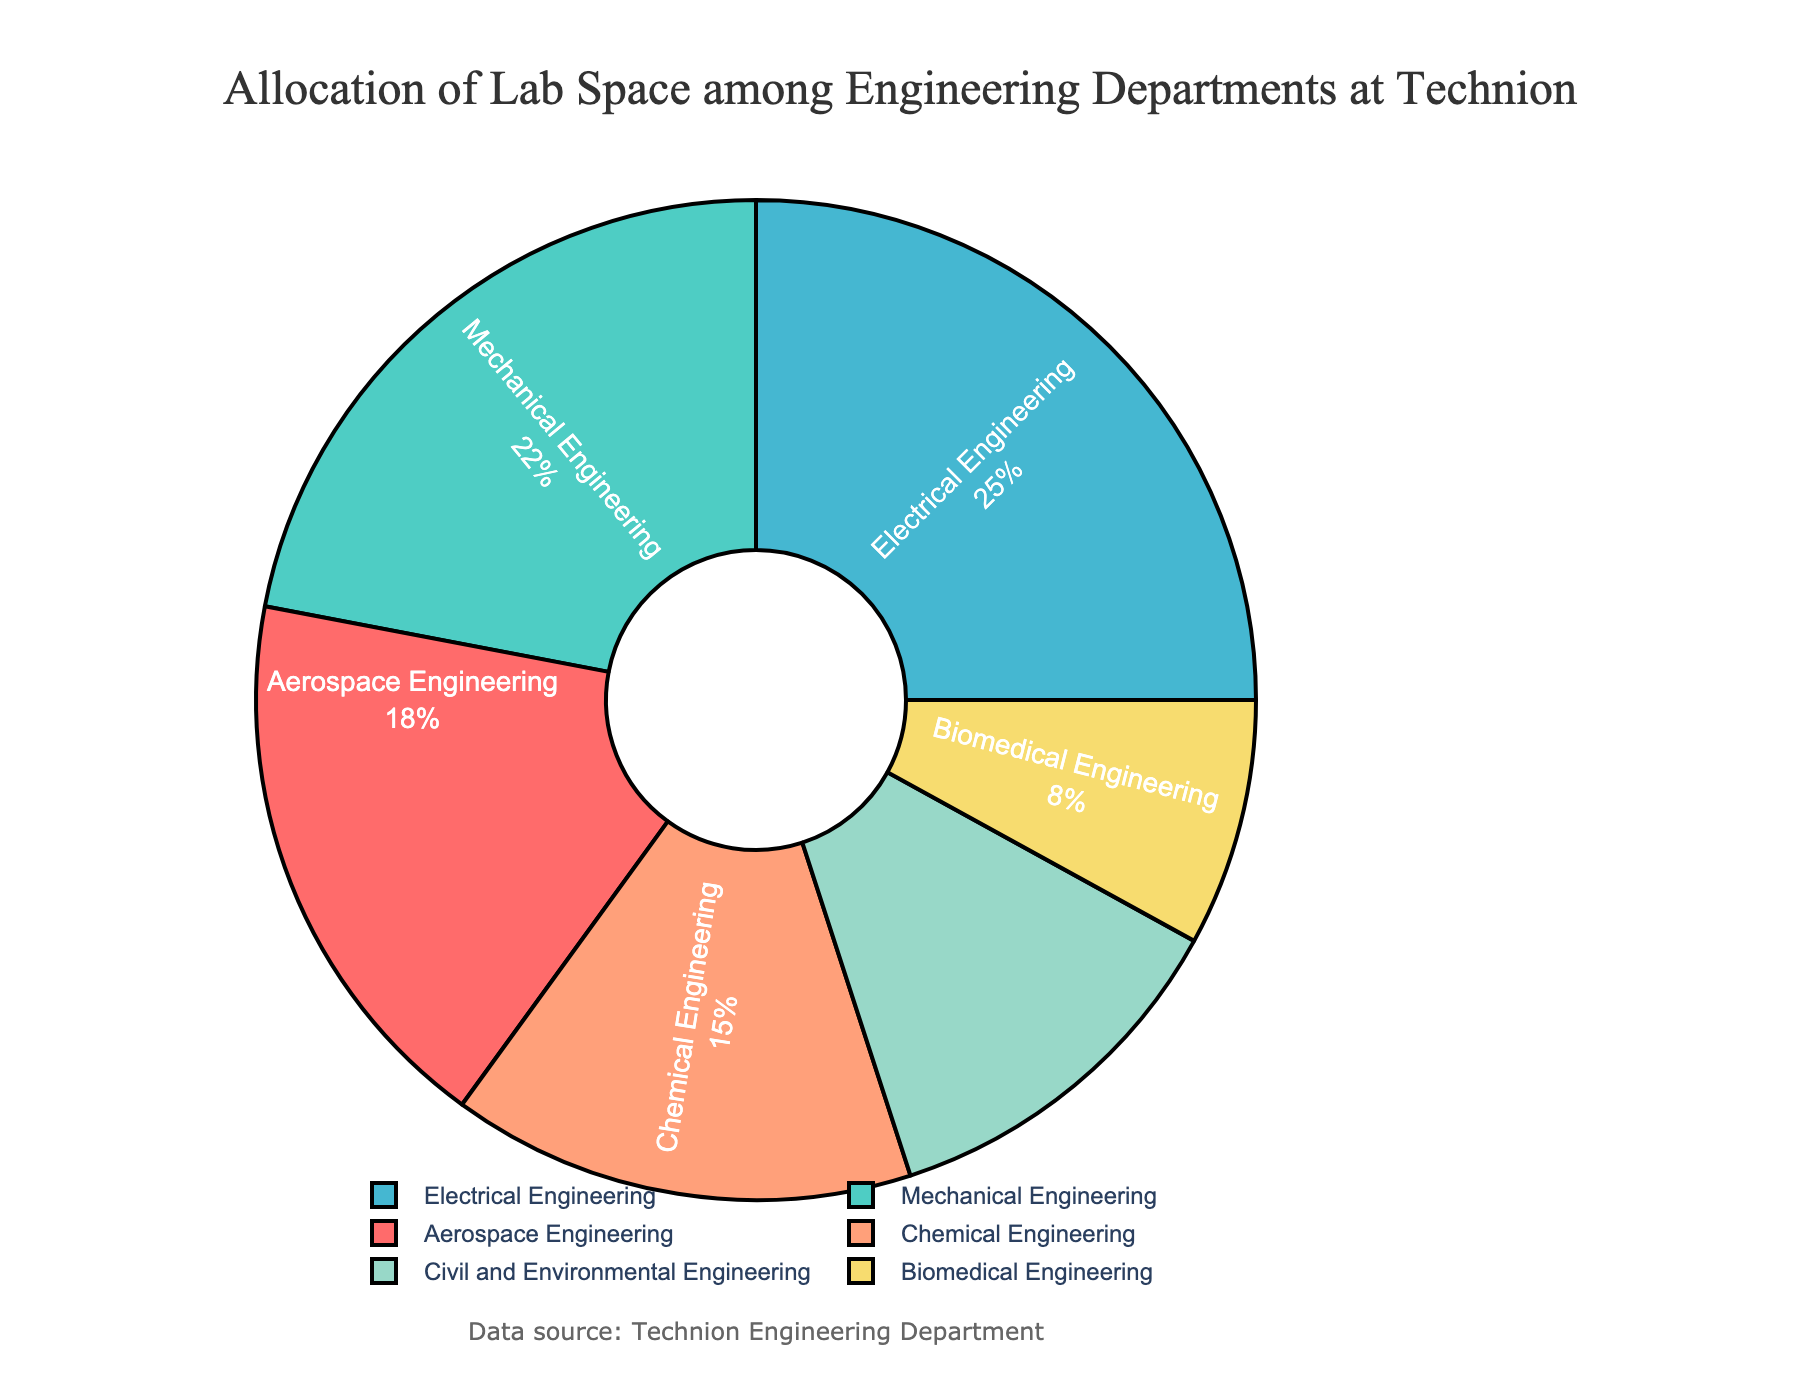What's the department with the largest allocation of lab space? Upon examining the pie chart, identify the department with the largest percentage. The slice labeled "Electrical Engineering" is the largest at 25%.
Answer: Electrical Engineering What is the total lab space allocation for Aerospace Engineering and Biomedical Engineering combined? Aerospace Engineering has an 18% allocation and Biomedical Engineering has an 8% allocation. Add these percentages together: 18% + 8% = 26%.
Answer: 26% Which two departments have equal or nearly equal lab space allocations? Look at the chart and compare the percentages. Biomedical Engineering (8%) and Civil and Environmental Engineering (12%) have the closest percentages, but not equal. None are equal.
Answer: None How much more lab space does Mechanical Engineering have than Chemical Engineering? Mechanical Engineering has 22% and Chemical Engineering has 15%. Subtract Chemical Engineering's percentage from Mechanical Engineering's: 22% - 15% = 7%.
Answer: 7% If the total lab space is 10,000 square meters, how much space is allocated to Civil and Environmental Engineering? Civil and Environmental Engineering has 12%. Calculate 12% of 10,000 square meters: 0.12 * 10,000 = 1,200 square meters.
Answer: 1,200 What colors represent the Chemical Engineering and Mechanical Engineering slices? Identifying colors in the pie chart, Chemical Engineering is represented by a light orange color and Mechanical Engineering is represented by a teal color.
Answer: Light orange and teal What is the difference in lab space allocation percentages between the department with the highest percentage and the department with the lowest percentage? The department with the highest percentage is Electrical Engineering at 25%, and the lowest is Biomedical Engineering at 8%. Subtract 8% from 25%: 25% - 8% = 17%.
Answer: 17% How many departments have less than 20% lab space allocation? To find the departments with less than 20%, look at each percentage: Aerospace Engineering (18%), Chemical Engineering (15%), Civil and Environmental Engineering (12%), and Biomedical Engineering (8%). Four departments have less than 20%.
Answer: Four 